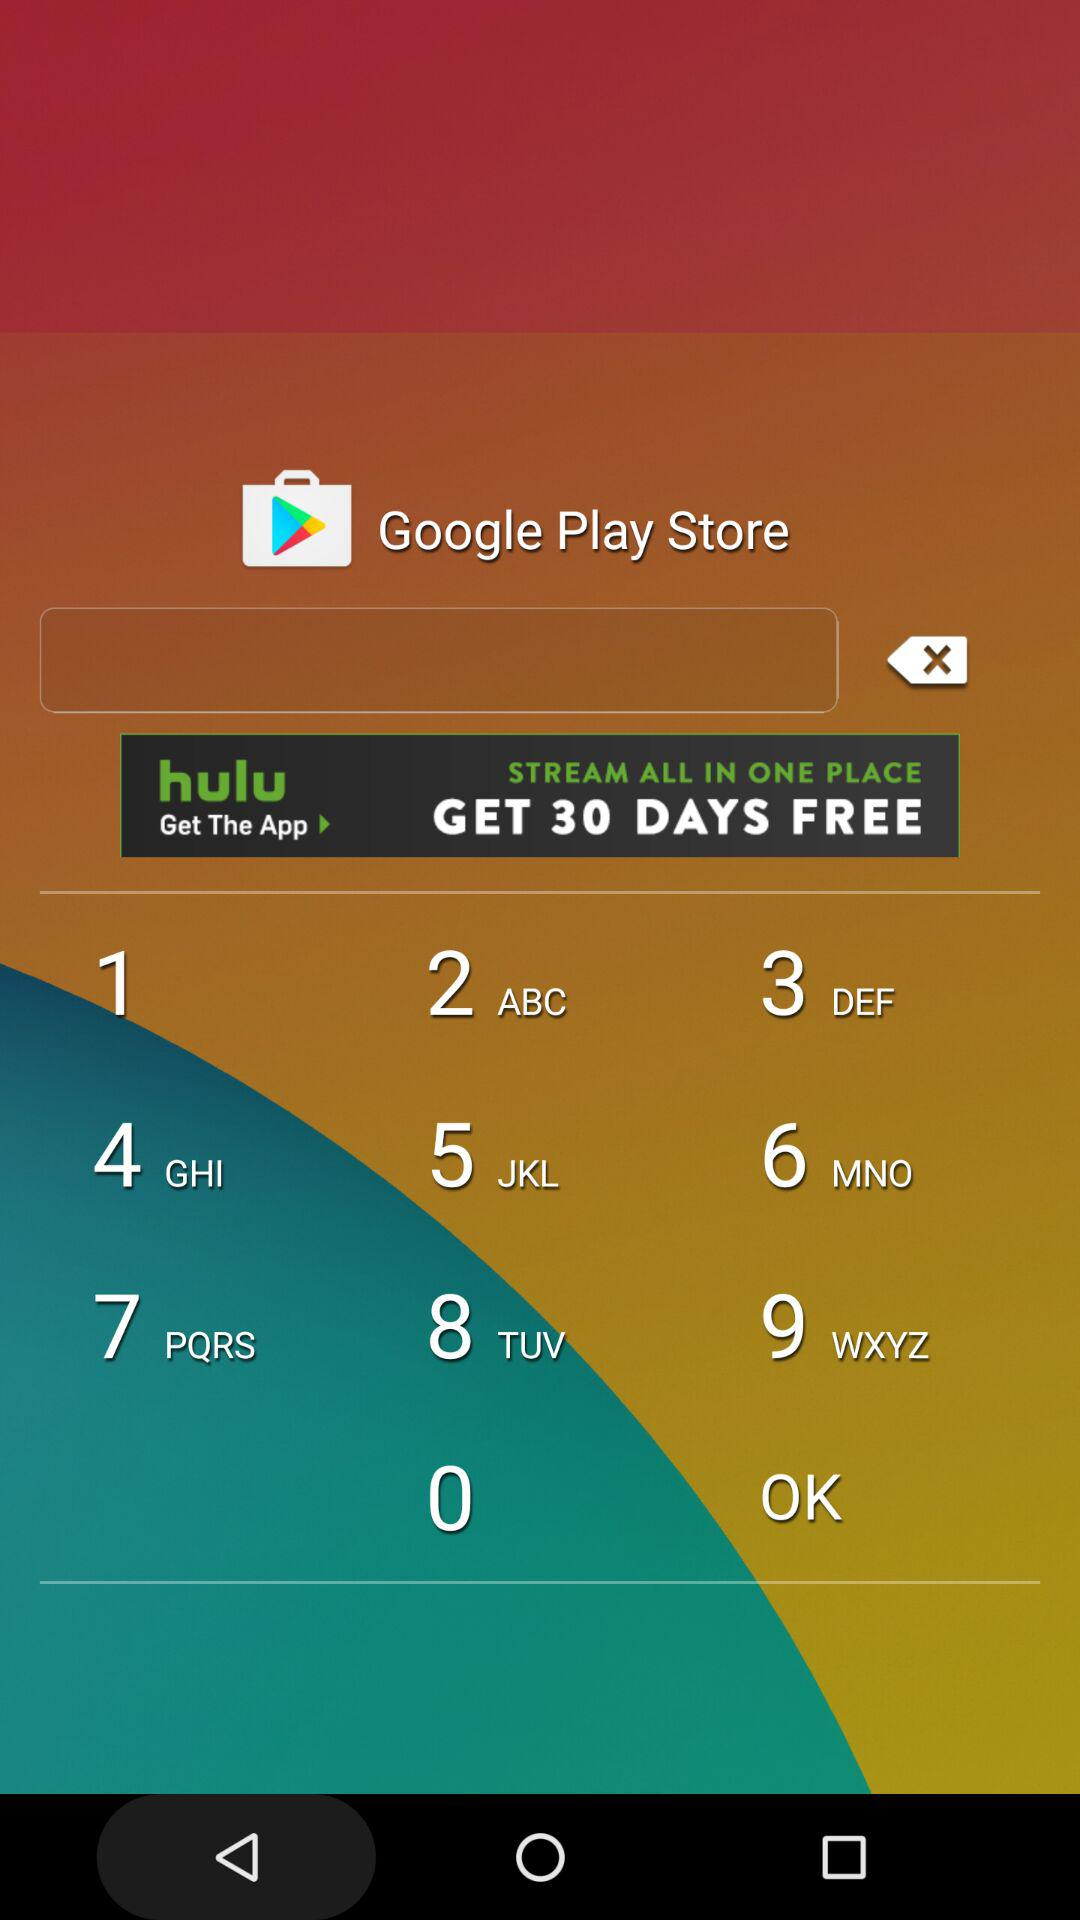What is the distance for the "Claiming" race? The distance for the "Claiming" race is 1 mile and 70 yards. 